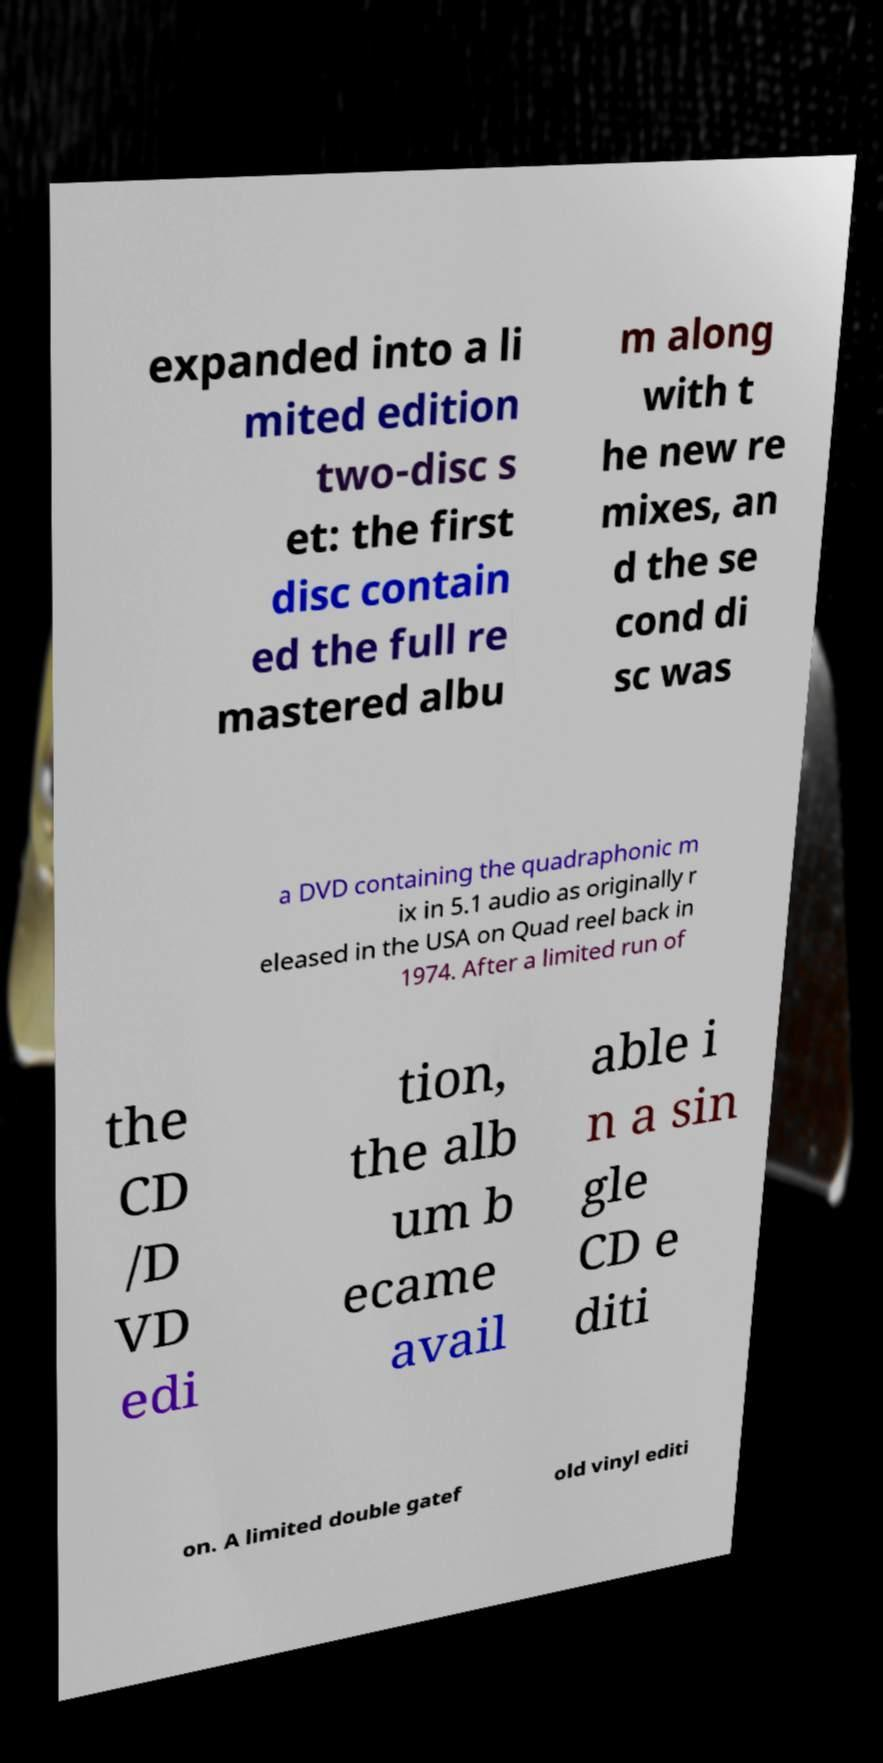Could you assist in decoding the text presented in this image and type it out clearly? expanded into a li mited edition two-disc s et: the first disc contain ed the full re mastered albu m along with t he new re mixes, an d the se cond di sc was a DVD containing the quadraphonic m ix in 5.1 audio as originally r eleased in the USA on Quad reel back in 1974. After a limited run of the CD /D VD edi tion, the alb um b ecame avail able i n a sin gle CD e diti on. A limited double gatef old vinyl editi 